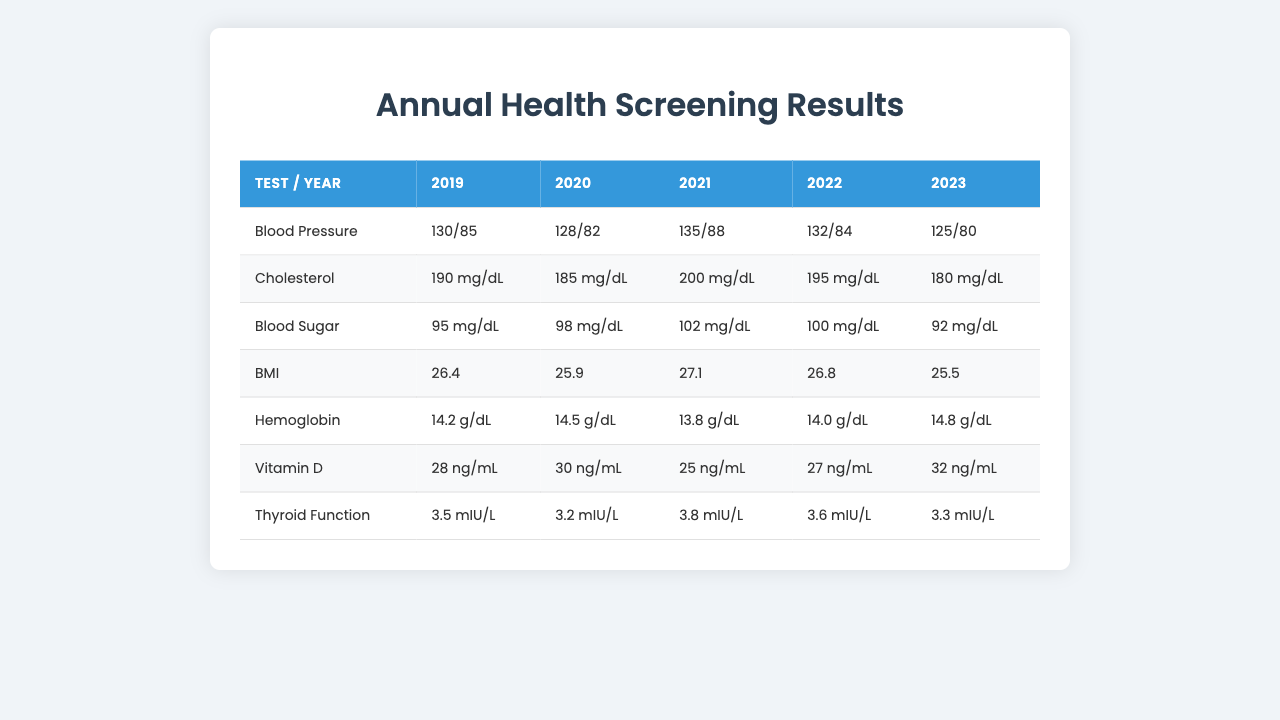What was the blood pressure reading in 2022? Looking at the row for "Blood Pressure" and the column for the year 2022, the value is "132/84".
Answer: 132/84 In which year did the cholesterol level reach its highest? By examining the "Cholesterol" row, the highest value is "200 mg/dL", which occurred in 2021.
Answer: 2021 What is the average BMI value over the years? The BMI values are 26.4, 25.9, 27.1, 26.8, and 25.5. The sum is 132.8, and since there are 5 years, the average is 132.8/5 = 26.56.
Answer: 26.56 Did the hemoglobin levels increase from 2019 to 2023? The hemoglobin values over the years are 14.2 g/dL for 2019 and 14.8 g/dL for 2023. Since 14.8 is greater than 14.2, it indicates an increase.
Answer: Yes What was the lowest thyroid function value recorded? Checking the "Thyroid Function" row, the values are 3.5, 3.2, 3.8, 3.6, and 3.3 mIU/L. The lowest value is 3.2 mIU/L in 2020.
Answer: 3.2 mIU/L Was the vitamin D level consistently below 30 ng/mL from 2019 to 2021? The vitamin D values are 28, 30, 25, and 27 ng/mL for 2019, 2020, and 2021 respectively. Since 30 in 2020 is not below 30, the statement is false.
Answer: No Which test showed the most variation across the years? By examining each test’s values, cholesterol had the most variation: 190, 185, 200, 195, and 180 mg/dL. The range is 200 - 180 = 20 mg/dL, which is greater than the variation in other tests.
Answer: Cholesterol What was the change in blood sugar levels between 2019 and 2023? The blood sugar readings were 95 mg/dL in 2019 and 92 mg/dL in 2023. The change is 92 - 95 = -3 mg/dL, indicating a decrease.
Answer: Decrease of 3 mg/dL In which year did the Vitamin D level show a significant drop? Comparing the values, the Vitamin D level dropped from 30 ng/mL in 2020 to 25 ng/mL in 2021, a noticeable decrease of 5 ng/mL.
Answer: 2021 What is the highest blood pressure reading recorded in these years? The highest blood pressure value is "135/88" in 2021.
Answer: 135/88 Is there a trend in BMI values over the years? The BMI values are showing a slight increase from 2019 (26.4) to 2021 (27.1), then a slight decrease to 25.5 in 2023, indicating fluctuations but no clear upward or downward trend.
Answer: Fluctuating trend 